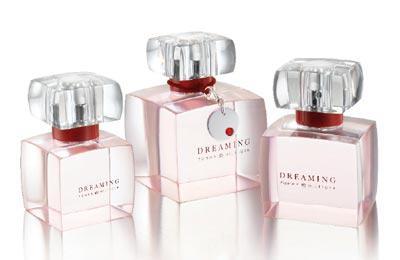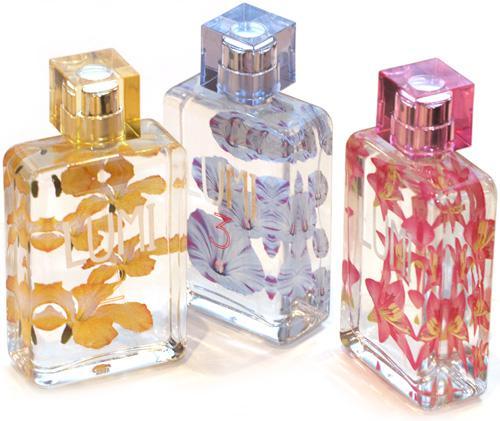The first image is the image on the left, the second image is the image on the right. Considering the images on both sides, is "One image includes a single perfume bottle, which has a pink non-square top." valid? Answer yes or no. No. 